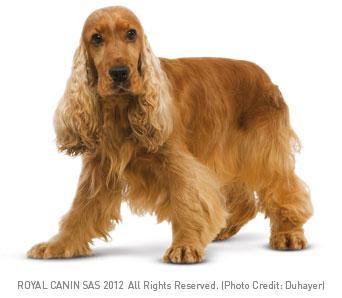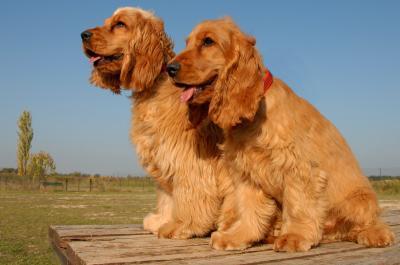The first image is the image on the left, the second image is the image on the right. Given the left and right images, does the statement "The dogs on the left image have plain white background." hold true? Answer yes or no. Yes. 